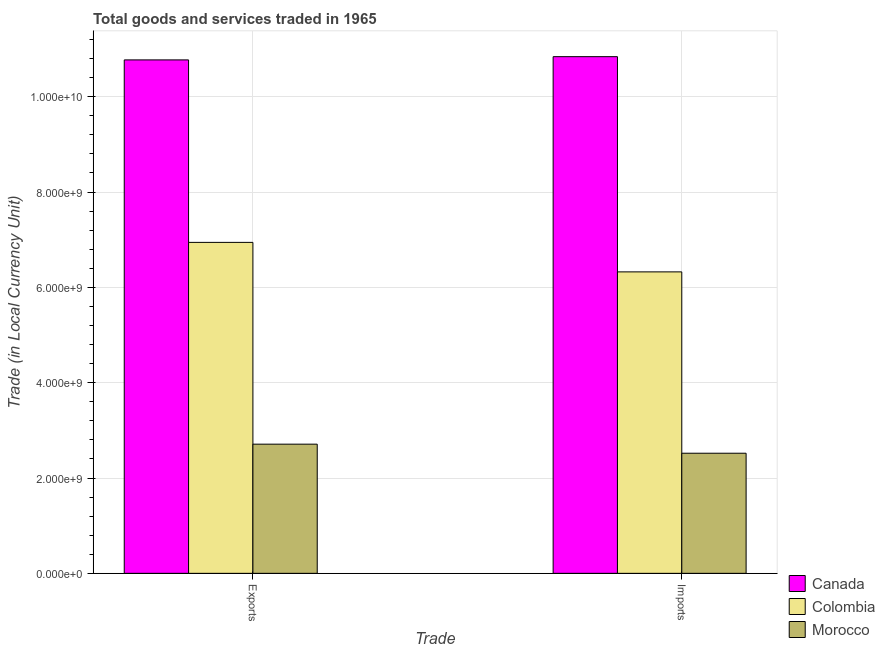How many different coloured bars are there?
Ensure brevity in your answer.  3. Are the number of bars per tick equal to the number of legend labels?
Ensure brevity in your answer.  Yes. What is the label of the 1st group of bars from the left?
Provide a succinct answer. Exports. What is the imports of goods and services in Colombia?
Offer a terse response. 6.32e+09. Across all countries, what is the maximum imports of goods and services?
Your answer should be very brief. 1.08e+1. Across all countries, what is the minimum imports of goods and services?
Your response must be concise. 2.52e+09. In which country was the export of goods and services minimum?
Your answer should be compact. Morocco. What is the total export of goods and services in the graph?
Provide a succinct answer. 2.04e+1. What is the difference between the export of goods and services in Colombia and that in Canada?
Ensure brevity in your answer.  -3.83e+09. What is the difference between the export of goods and services in Morocco and the imports of goods and services in Canada?
Offer a very short reply. -8.13e+09. What is the average export of goods and services per country?
Make the answer very short. 6.81e+09. What is the difference between the export of goods and services and imports of goods and services in Morocco?
Your answer should be very brief. 1.90e+08. What is the ratio of the export of goods and services in Canada to that in Morocco?
Your answer should be very brief. 3.97. Is the imports of goods and services in Canada less than that in Colombia?
Make the answer very short. No. In how many countries, is the export of goods and services greater than the average export of goods and services taken over all countries?
Your answer should be compact. 2. How many bars are there?
Provide a short and direct response. 6. Are all the bars in the graph horizontal?
Your response must be concise. No. Does the graph contain any zero values?
Your response must be concise. No. Does the graph contain grids?
Provide a short and direct response. Yes. How many legend labels are there?
Make the answer very short. 3. How are the legend labels stacked?
Ensure brevity in your answer.  Vertical. What is the title of the graph?
Give a very brief answer. Total goods and services traded in 1965. What is the label or title of the X-axis?
Your response must be concise. Trade. What is the label or title of the Y-axis?
Give a very brief answer. Trade (in Local Currency Unit). What is the Trade (in Local Currency Unit) in Canada in Exports?
Offer a very short reply. 1.08e+1. What is the Trade (in Local Currency Unit) in Colombia in Exports?
Your answer should be compact. 6.94e+09. What is the Trade (in Local Currency Unit) in Morocco in Exports?
Provide a short and direct response. 2.71e+09. What is the Trade (in Local Currency Unit) of Canada in Imports?
Keep it short and to the point. 1.08e+1. What is the Trade (in Local Currency Unit) of Colombia in Imports?
Make the answer very short. 6.32e+09. What is the Trade (in Local Currency Unit) of Morocco in Imports?
Provide a succinct answer. 2.52e+09. Across all Trade, what is the maximum Trade (in Local Currency Unit) of Canada?
Ensure brevity in your answer.  1.08e+1. Across all Trade, what is the maximum Trade (in Local Currency Unit) of Colombia?
Keep it short and to the point. 6.94e+09. Across all Trade, what is the maximum Trade (in Local Currency Unit) of Morocco?
Your answer should be very brief. 2.71e+09. Across all Trade, what is the minimum Trade (in Local Currency Unit) in Canada?
Provide a succinct answer. 1.08e+1. Across all Trade, what is the minimum Trade (in Local Currency Unit) in Colombia?
Keep it short and to the point. 6.32e+09. Across all Trade, what is the minimum Trade (in Local Currency Unit) in Morocco?
Make the answer very short. 2.52e+09. What is the total Trade (in Local Currency Unit) in Canada in the graph?
Provide a succinct answer. 2.16e+1. What is the total Trade (in Local Currency Unit) in Colombia in the graph?
Ensure brevity in your answer.  1.33e+1. What is the total Trade (in Local Currency Unit) of Morocco in the graph?
Your response must be concise. 5.23e+09. What is the difference between the Trade (in Local Currency Unit) in Canada in Exports and that in Imports?
Your response must be concise. -6.80e+07. What is the difference between the Trade (in Local Currency Unit) in Colombia in Exports and that in Imports?
Make the answer very short. 6.19e+08. What is the difference between the Trade (in Local Currency Unit) in Morocco in Exports and that in Imports?
Provide a succinct answer. 1.90e+08. What is the difference between the Trade (in Local Currency Unit) of Canada in Exports and the Trade (in Local Currency Unit) of Colombia in Imports?
Ensure brevity in your answer.  4.45e+09. What is the difference between the Trade (in Local Currency Unit) of Canada in Exports and the Trade (in Local Currency Unit) of Morocco in Imports?
Your answer should be compact. 8.25e+09. What is the difference between the Trade (in Local Currency Unit) in Colombia in Exports and the Trade (in Local Currency Unit) in Morocco in Imports?
Provide a succinct answer. 4.42e+09. What is the average Trade (in Local Currency Unit) of Canada per Trade?
Your response must be concise. 1.08e+1. What is the average Trade (in Local Currency Unit) of Colombia per Trade?
Keep it short and to the point. 6.63e+09. What is the average Trade (in Local Currency Unit) of Morocco per Trade?
Make the answer very short. 2.62e+09. What is the difference between the Trade (in Local Currency Unit) of Canada and Trade (in Local Currency Unit) of Colombia in Exports?
Make the answer very short. 3.83e+09. What is the difference between the Trade (in Local Currency Unit) of Canada and Trade (in Local Currency Unit) of Morocco in Exports?
Ensure brevity in your answer.  8.06e+09. What is the difference between the Trade (in Local Currency Unit) of Colombia and Trade (in Local Currency Unit) of Morocco in Exports?
Give a very brief answer. 4.23e+09. What is the difference between the Trade (in Local Currency Unit) of Canada and Trade (in Local Currency Unit) of Colombia in Imports?
Offer a terse response. 4.52e+09. What is the difference between the Trade (in Local Currency Unit) in Canada and Trade (in Local Currency Unit) in Morocco in Imports?
Offer a very short reply. 8.32e+09. What is the difference between the Trade (in Local Currency Unit) in Colombia and Trade (in Local Currency Unit) in Morocco in Imports?
Ensure brevity in your answer.  3.80e+09. What is the ratio of the Trade (in Local Currency Unit) of Colombia in Exports to that in Imports?
Offer a terse response. 1.1. What is the ratio of the Trade (in Local Currency Unit) in Morocco in Exports to that in Imports?
Give a very brief answer. 1.08. What is the difference between the highest and the second highest Trade (in Local Currency Unit) of Canada?
Make the answer very short. 6.80e+07. What is the difference between the highest and the second highest Trade (in Local Currency Unit) of Colombia?
Ensure brevity in your answer.  6.19e+08. What is the difference between the highest and the second highest Trade (in Local Currency Unit) in Morocco?
Your response must be concise. 1.90e+08. What is the difference between the highest and the lowest Trade (in Local Currency Unit) of Canada?
Offer a very short reply. 6.80e+07. What is the difference between the highest and the lowest Trade (in Local Currency Unit) of Colombia?
Keep it short and to the point. 6.19e+08. What is the difference between the highest and the lowest Trade (in Local Currency Unit) in Morocco?
Provide a short and direct response. 1.90e+08. 